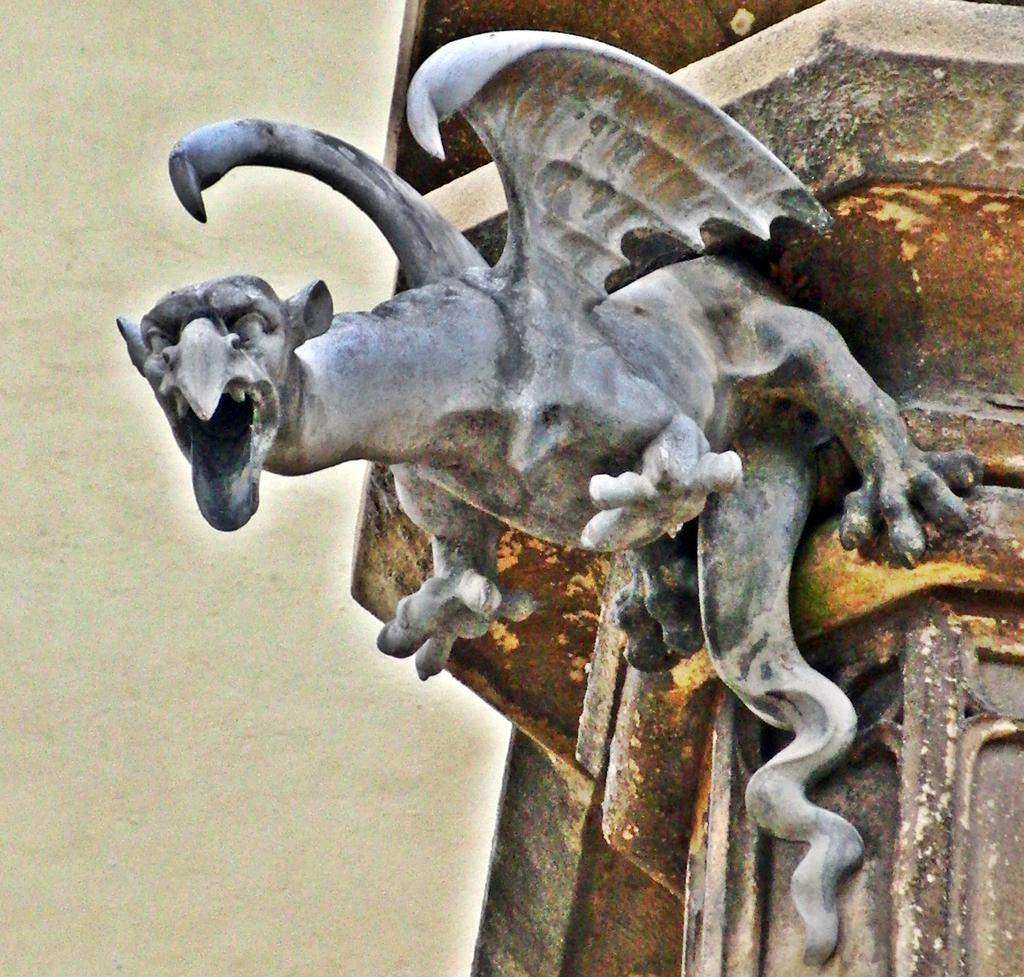What is on the wall in the image? There is a sculpture on the wall in the image. How many jellyfish are swimming in the sculpture in the image? There are no jellyfish present in the image; the sculpture is the only subject mentioned in the provided fact. 